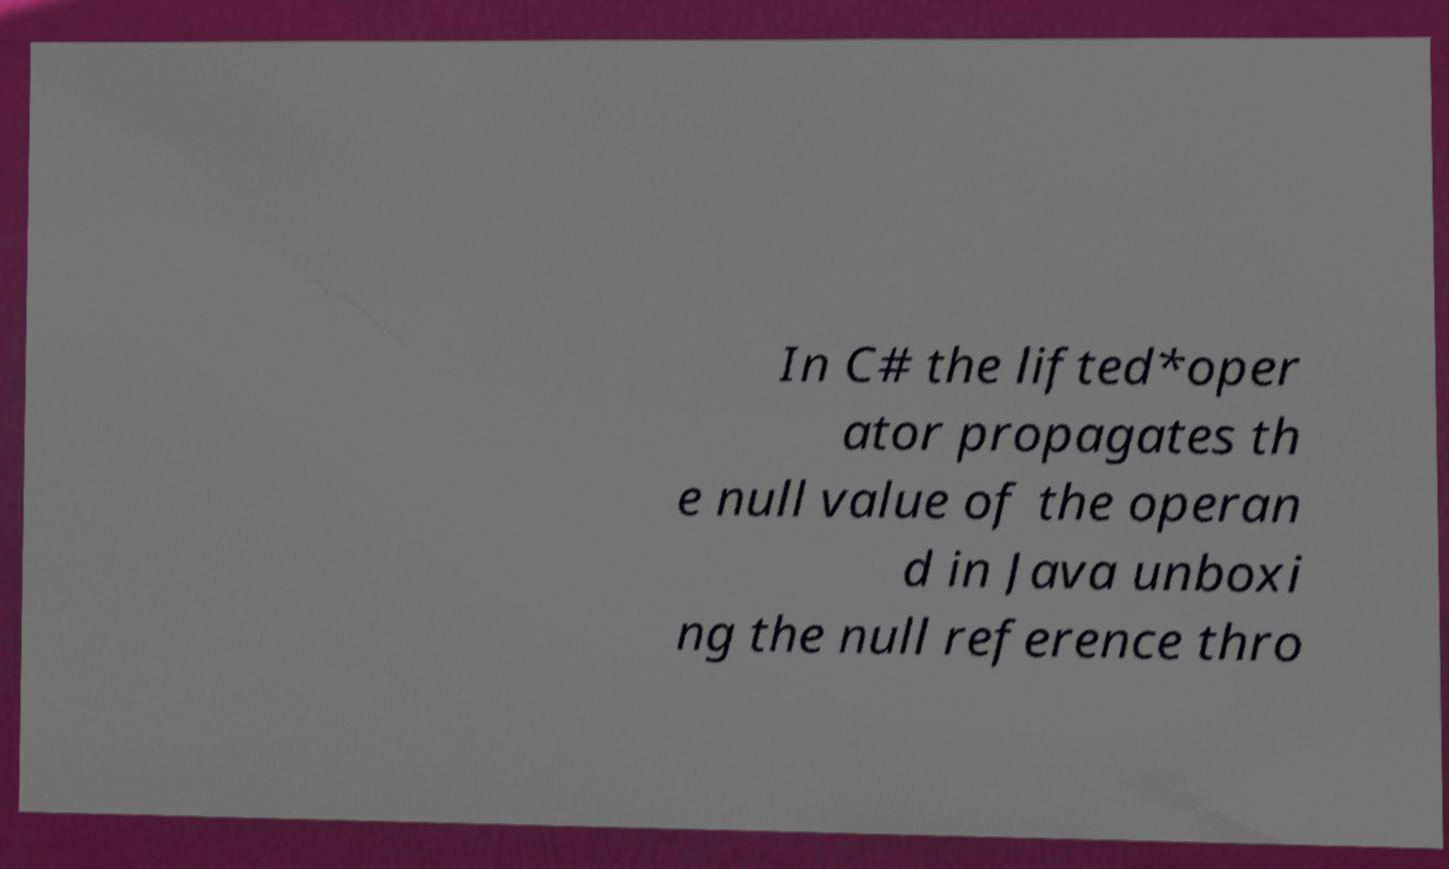For documentation purposes, I need the text within this image transcribed. Could you provide that? In C# the lifted*oper ator propagates th e null value of the operan d in Java unboxi ng the null reference thro 